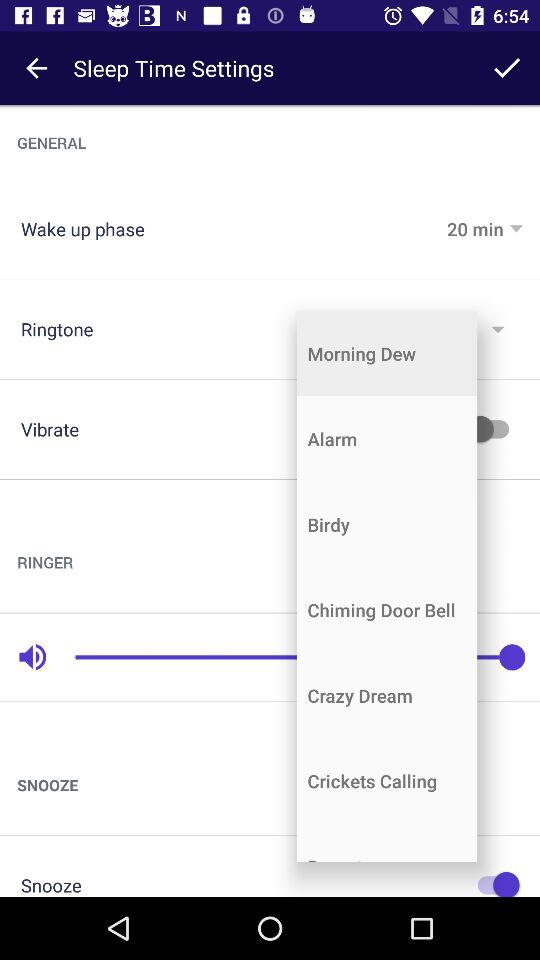What is the time interval for the "Wake up phase"? The time interval is 20 minutes. 